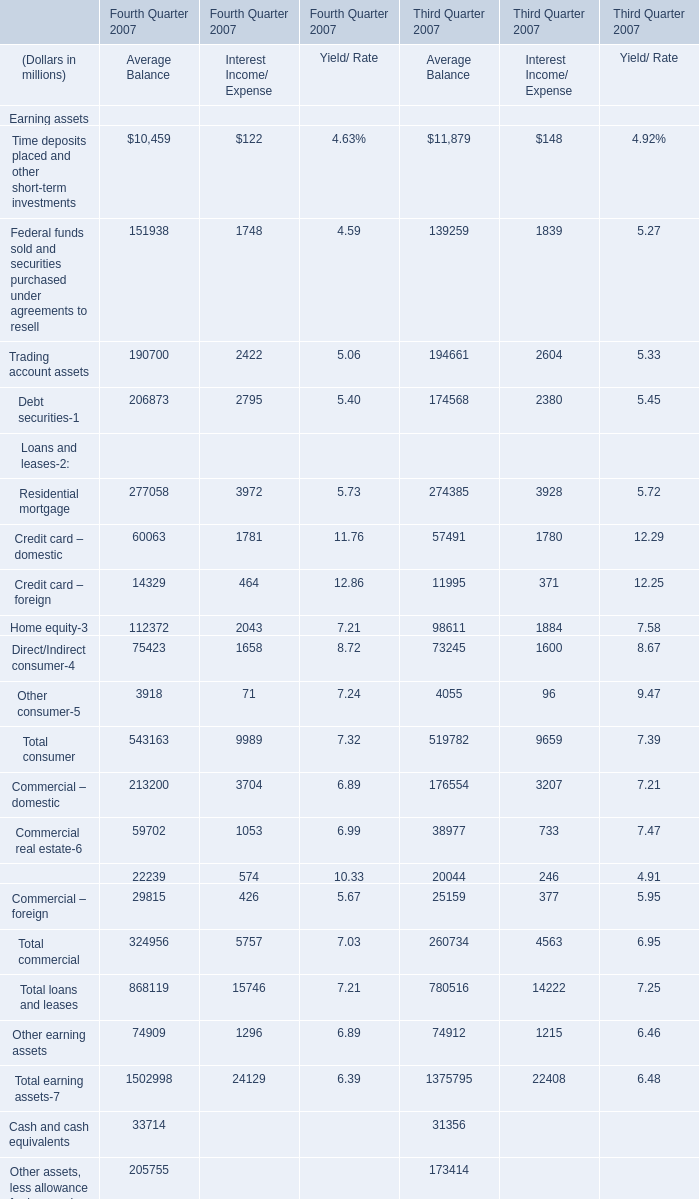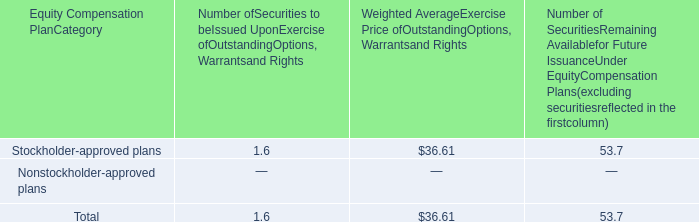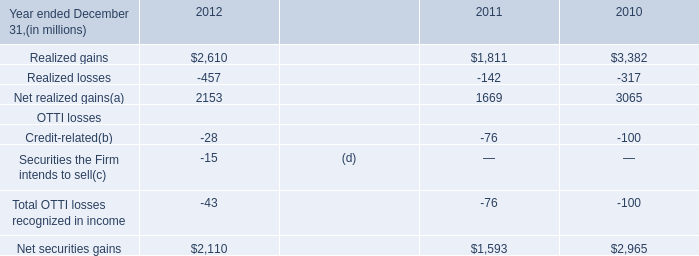What is the sum of Trading account assets of Average Balance for Fourth Quarter 2007 and Realized gains in 2012? (in million) 
Computations: (190700 + 2610)
Answer: 193310.0. 